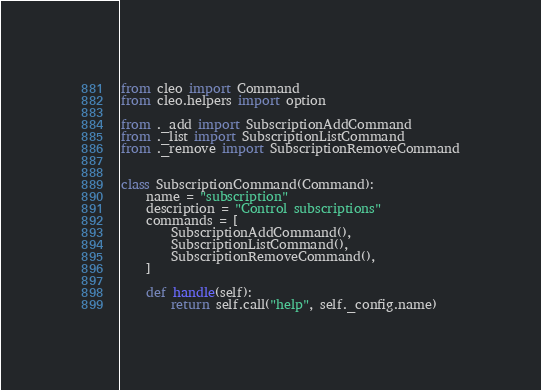<code> <loc_0><loc_0><loc_500><loc_500><_Python_>from cleo import Command
from cleo.helpers import option

from ._add import SubscriptionAddCommand
from ._list import SubscriptionListCommand
from ._remove import SubscriptionRemoveCommand


class SubscriptionCommand(Command):
    name = "subscription"
    description = "Control subscriptions"
    commands = [
        SubscriptionAddCommand(),
        SubscriptionListCommand(),
        SubscriptionRemoveCommand(),
    ]

    def handle(self):
        return self.call("help", self._config.name)
</code> 